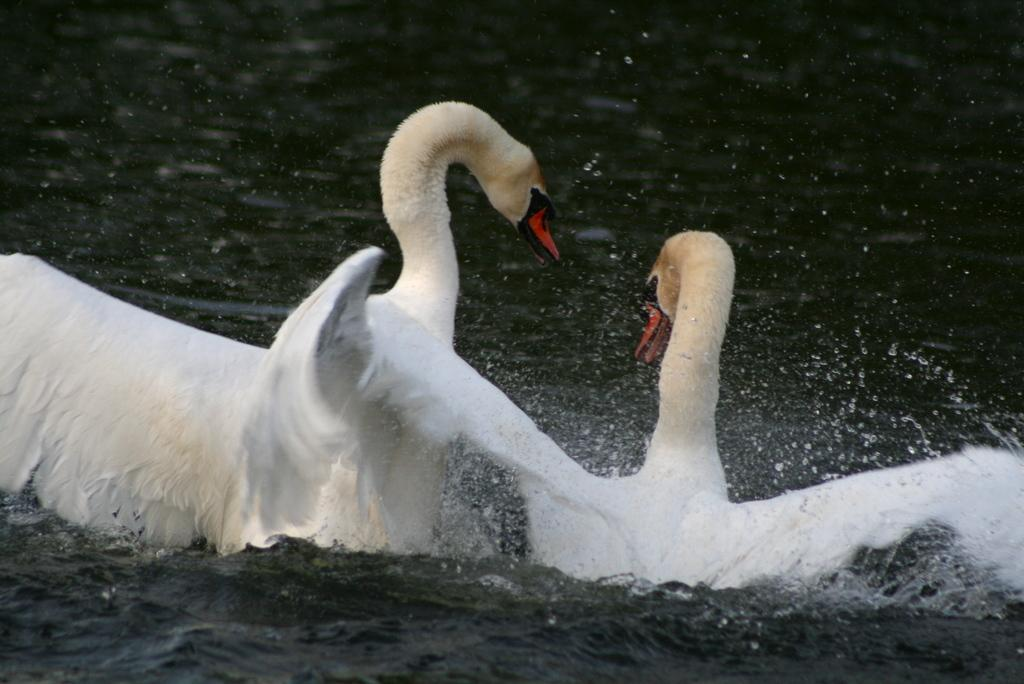What type of animals are in the image? There are swans in the image. What color are the swans? The swans are white in color. What is visible at the bottom of the image? There is water visible at the bottom of the image. Where is the stove located in the image? There is no stove present in the image. What type of patch can be seen on the swan's wing in the image? There are no patches visible on the swans' wings in the image. 